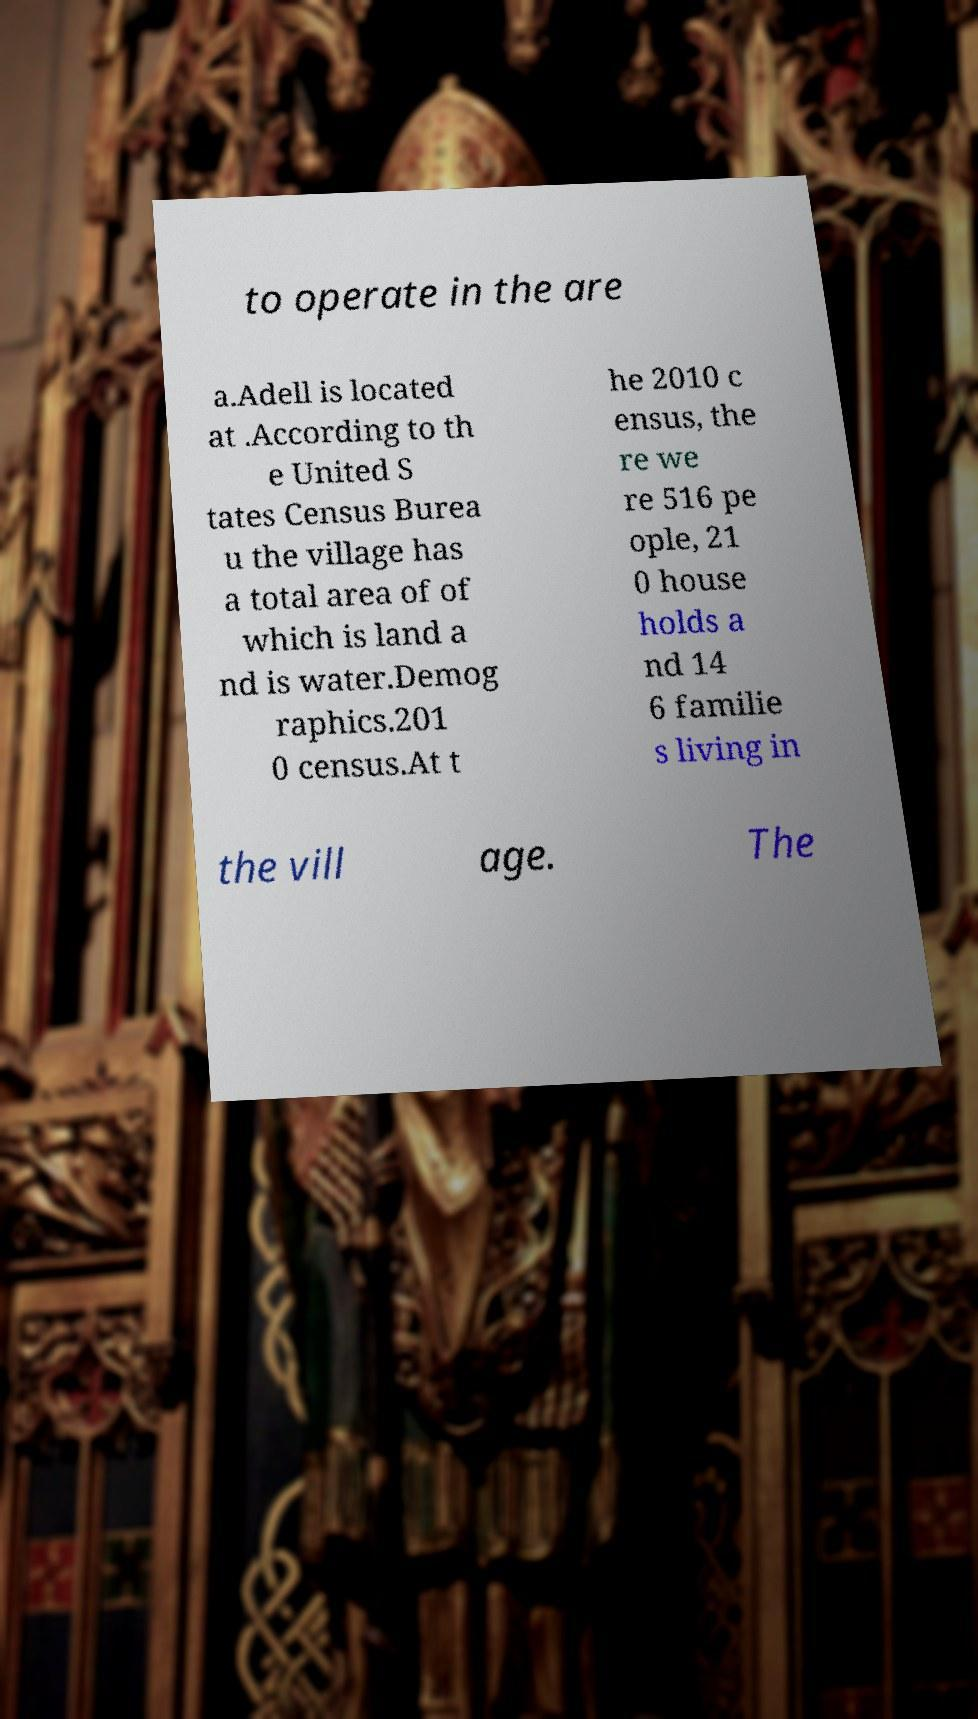There's text embedded in this image that I need extracted. Can you transcribe it verbatim? to operate in the are a.Adell is located at .According to th e United S tates Census Burea u the village has a total area of of which is land a nd is water.Demog raphics.201 0 census.At t he 2010 c ensus, the re we re 516 pe ople, 21 0 house holds a nd 14 6 familie s living in the vill age. The 